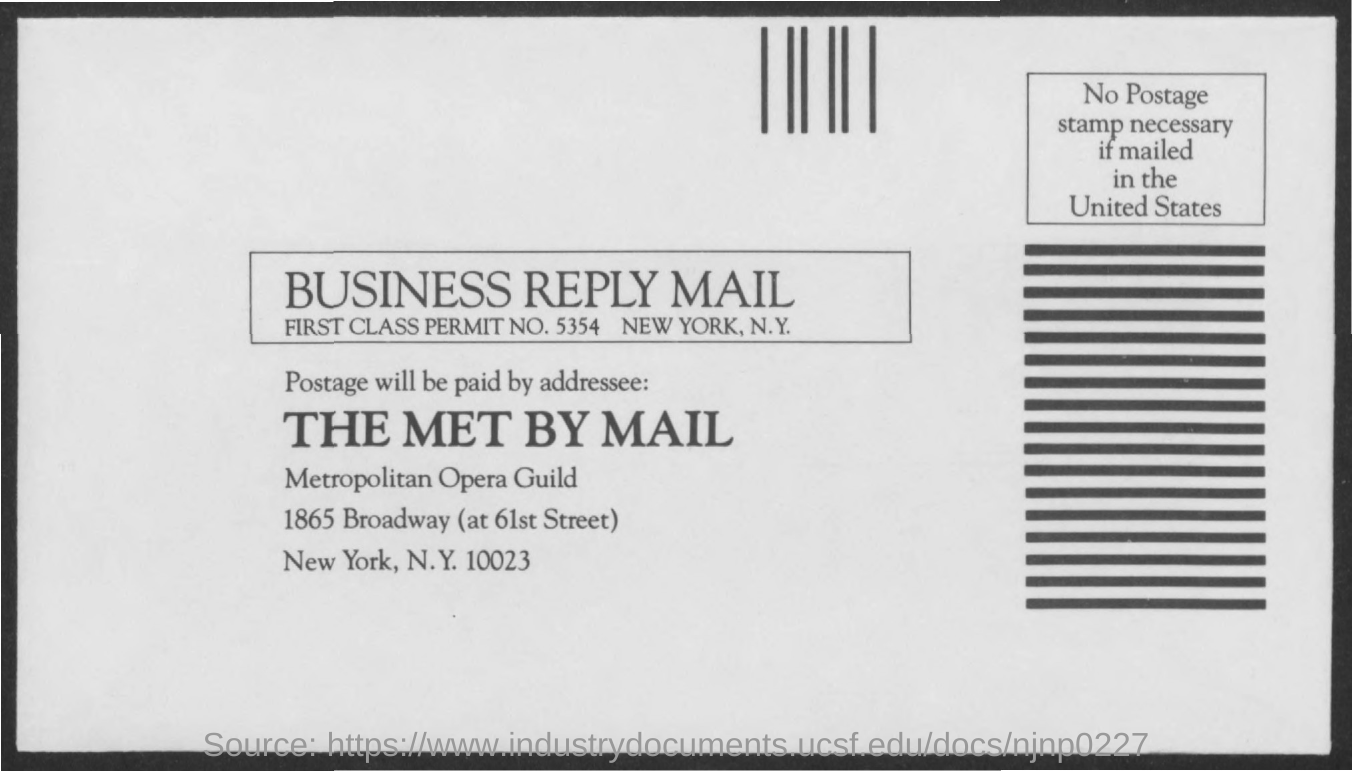Draw attention to some important aspects in this diagram. The first class permit number mentioned is 5354. 